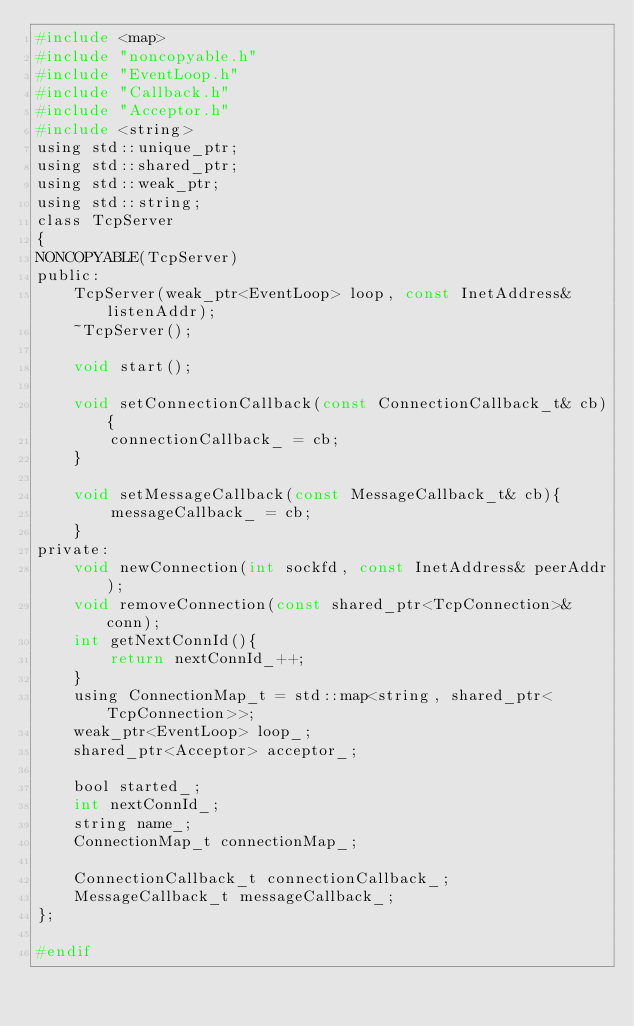Convert code to text. <code><loc_0><loc_0><loc_500><loc_500><_C_>#include <map>
#include "noncopyable.h"
#include "EventLoop.h"
#include "Callback.h"
#include "Acceptor.h"
#include <string>
using std::unique_ptr;
using std::shared_ptr;
using std::weak_ptr;
using std::string;
class TcpServer
{
NONCOPYABLE(TcpServer)
public:
    TcpServer(weak_ptr<EventLoop> loop, const InetAddress& listenAddr);
    ~TcpServer();

    void start();

    void setConnectionCallback(const ConnectionCallback_t& cb){
        connectionCallback_ = cb;
    }

    void setMessageCallback(const MessageCallback_t& cb){
        messageCallback_ = cb;
    }
private:
    void newConnection(int sockfd, const InetAddress& peerAddr);
    void removeConnection(const shared_ptr<TcpConnection>& conn);
    int getNextConnId(){
        return nextConnId_++;
    }
    using ConnectionMap_t = std::map<string, shared_ptr<TcpConnection>>;
    weak_ptr<EventLoop> loop_;
    shared_ptr<Acceptor> acceptor_;

    bool started_;
    int nextConnId_;
    string name_;
    ConnectionMap_t connectionMap_;

    ConnectionCallback_t connectionCallback_;
    MessageCallback_t messageCallback_;
};

#endif</code> 